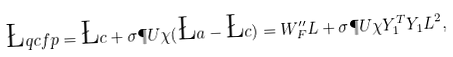<formula> <loc_0><loc_0><loc_500><loc_500>\L q c f p = \L c + \sigma \P U \chi ( \L a - \L c ) = W _ { F } ^ { \prime \prime } L + \sigma \P U \chi Y _ { 1 } ^ { T } Y _ { 1 } L ^ { 2 } ,</formula> 